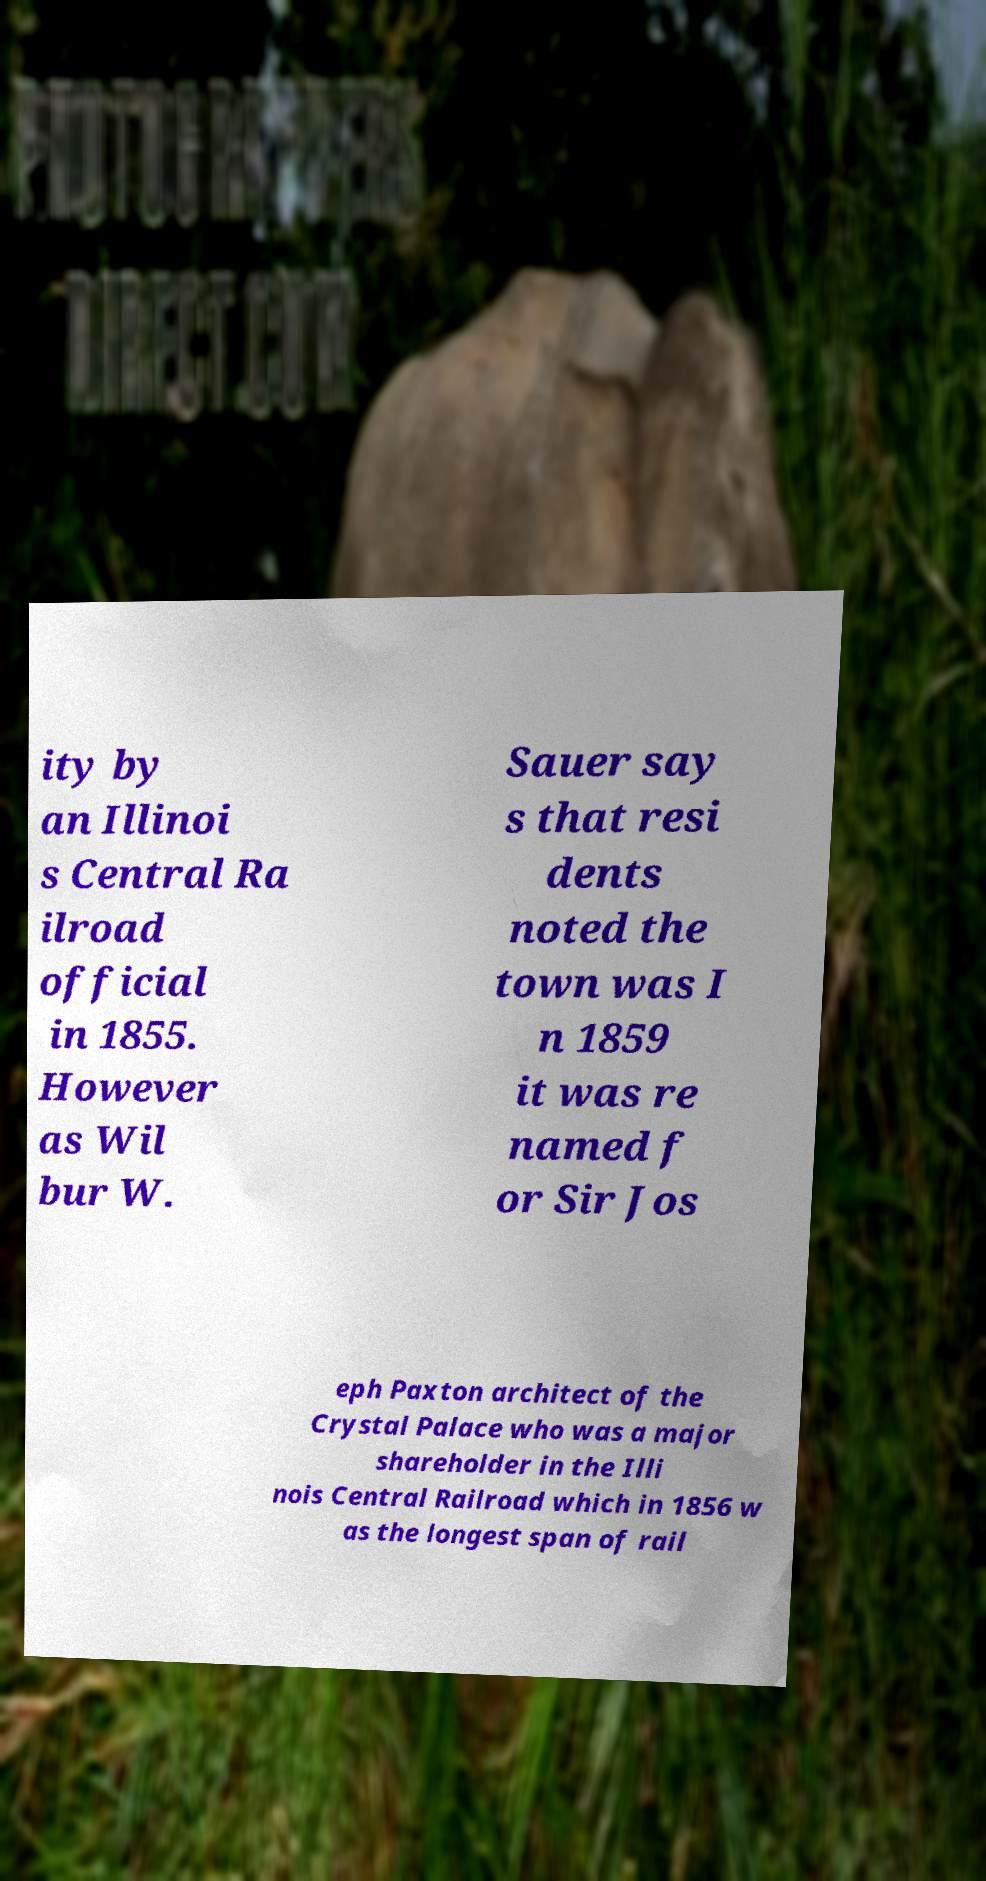Please read and relay the text visible in this image. What does it say? ity by an Illinoi s Central Ra ilroad official in 1855. However as Wil bur W. Sauer say s that resi dents noted the town was I n 1859 it was re named f or Sir Jos eph Paxton architect of the Crystal Palace who was a major shareholder in the Illi nois Central Railroad which in 1856 w as the longest span of rail 